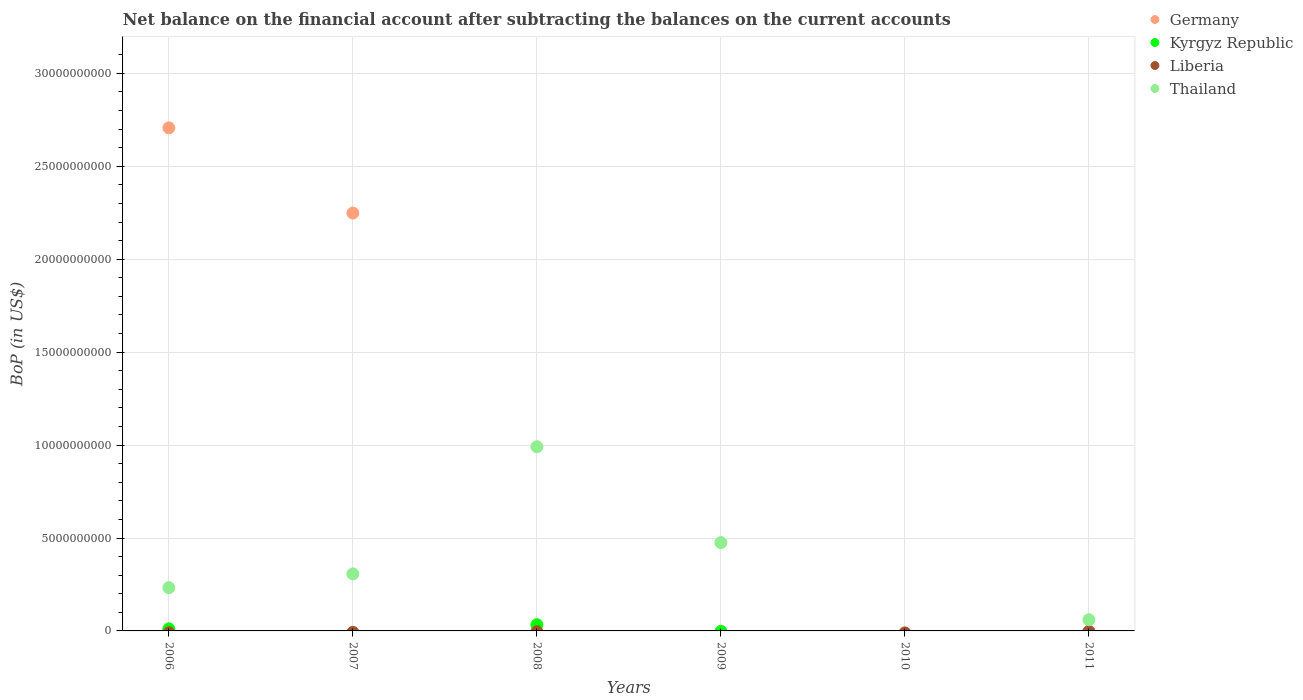Is the number of dotlines equal to the number of legend labels?
Your answer should be very brief. No. What is the Balance of Payments in Liberia in 2011?
Make the answer very short. 0. Across all years, what is the maximum Balance of Payments in Thailand?
Your response must be concise. 9.91e+09. What is the total Balance of Payments in Kyrgyz Republic in the graph?
Make the answer very short. 4.45e+08. What is the difference between the Balance of Payments in Germany in 2006 and that in 2007?
Your response must be concise. 4.58e+09. What is the difference between the Balance of Payments in Liberia in 2011 and the Balance of Payments in Thailand in 2009?
Give a very brief answer. -4.75e+09. What is the average Balance of Payments in Germany per year?
Your response must be concise. 8.26e+09. In the year 2007, what is the difference between the Balance of Payments in Thailand and Balance of Payments in Germany?
Offer a very short reply. -1.94e+1. What is the ratio of the Balance of Payments in Germany in 2006 to that in 2007?
Your answer should be very brief. 1.2. What is the difference between the highest and the lowest Balance of Payments in Thailand?
Ensure brevity in your answer.  9.91e+09. Is it the case that in every year, the sum of the Balance of Payments in Thailand and Balance of Payments in Liberia  is greater than the sum of Balance of Payments in Kyrgyz Republic and Balance of Payments in Germany?
Your response must be concise. No. Is the Balance of Payments in Thailand strictly less than the Balance of Payments in Germany over the years?
Your response must be concise. No. How many dotlines are there?
Your answer should be very brief. 3. Are the values on the major ticks of Y-axis written in scientific E-notation?
Provide a short and direct response. No. Does the graph contain grids?
Provide a short and direct response. Yes. What is the title of the graph?
Your answer should be very brief. Net balance on the financial account after subtracting the balances on the current accounts. Does "Saudi Arabia" appear as one of the legend labels in the graph?
Your answer should be very brief. No. What is the label or title of the X-axis?
Provide a succinct answer. Years. What is the label or title of the Y-axis?
Your response must be concise. BoP (in US$). What is the BoP (in US$) in Germany in 2006?
Keep it short and to the point. 2.71e+1. What is the BoP (in US$) of Kyrgyz Republic in 2006?
Keep it short and to the point. 1.10e+08. What is the BoP (in US$) of Thailand in 2006?
Provide a succinct answer. 2.33e+09. What is the BoP (in US$) in Germany in 2007?
Make the answer very short. 2.25e+1. What is the BoP (in US$) of Kyrgyz Republic in 2007?
Your response must be concise. 0. What is the BoP (in US$) of Liberia in 2007?
Make the answer very short. 0. What is the BoP (in US$) of Thailand in 2007?
Keep it short and to the point. 3.07e+09. What is the BoP (in US$) of Germany in 2008?
Give a very brief answer. 0. What is the BoP (in US$) of Kyrgyz Republic in 2008?
Your response must be concise. 3.34e+08. What is the BoP (in US$) in Thailand in 2008?
Provide a succinct answer. 9.91e+09. What is the BoP (in US$) in Germany in 2009?
Your response must be concise. 0. What is the BoP (in US$) of Thailand in 2009?
Give a very brief answer. 4.75e+09. What is the BoP (in US$) in Germany in 2011?
Ensure brevity in your answer.  0. What is the BoP (in US$) in Kyrgyz Republic in 2011?
Give a very brief answer. 0. What is the BoP (in US$) of Thailand in 2011?
Your answer should be compact. 6.01e+08. Across all years, what is the maximum BoP (in US$) of Germany?
Offer a very short reply. 2.71e+1. Across all years, what is the maximum BoP (in US$) of Kyrgyz Republic?
Keep it short and to the point. 3.34e+08. Across all years, what is the maximum BoP (in US$) of Thailand?
Provide a succinct answer. 9.91e+09. Across all years, what is the minimum BoP (in US$) of Germany?
Your response must be concise. 0. Across all years, what is the minimum BoP (in US$) in Thailand?
Ensure brevity in your answer.  0. What is the total BoP (in US$) of Germany in the graph?
Provide a short and direct response. 4.96e+1. What is the total BoP (in US$) in Kyrgyz Republic in the graph?
Provide a succinct answer. 4.45e+08. What is the total BoP (in US$) in Liberia in the graph?
Your response must be concise. 0. What is the total BoP (in US$) of Thailand in the graph?
Make the answer very short. 2.07e+1. What is the difference between the BoP (in US$) of Germany in 2006 and that in 2007?
Give a very brief answer. 4.58e+09. What is the difference between the BoP (in US$) of Thailand in 2006 and that in 2007?
Ensure brevity in your answer.  -7.42e+08. What is the difference between the BoP (in US$) in Kyrgyz Republic in 2006 and that in 2008?
Your answer should be very brief. -2.24e+08. What is the difference between the BoP (in US$) in Thailand in 2006 and that in 2008?
Offer a terse response. -7.58e+09. What is the difference between the BoP (in US$) of Thailand in 2006 and that in 2009?
Offer a very short reply. -2.42e+09. What is the difference between the BoP (in US$) in Thailand in 2006 and that in 2011?
Your answer should be very brief. 1.73e+09. What is the difference between the BoP (in US$) of Thailand in 2007 and that in 2008?
Your response must be concise. -6.84e+09. What is the difference between the BoP (in US$) in Thailand in 2007 and that in 2009?
Ensure brevity in your answer.  -1.68e+09. What is the difference between the BoP (in US$) in Thailand in 2007 and that in 2011?
Provide a succinct answer. 2.47e+09. What is the difference between the BoP (in US$) of Thailand in 2008 and that in 2009?
Provide a short and direct response. 5.16e+09. What is the difference between the BoP (in US$) of Thailand in 2008 and that in 2011?
Give a very brief answer. 9.31e+09. What is the difference between the BoP (in US$) in Thailand in 2009 and that in 2011?
Give a very brief answer. 4.15e+09. What is the difference between the BoP (in US$) in Germany in 2006 and the BoP (in US$) in Thailand in 2007?
Your response must be concise. 2.40e+1. What is the difference between the BoP (in US$) of Kyrgyz Republic in 2006 and the BoP (in US$) of Thailand in 2007?
Your answer should be compact. -2.96e+09. What is the difference between the BoP (in US$) in Germany in 2006 and the BoP (in US$) in Kyrgyz Republic in 2008?
Make the answer very short. 2.67e+1. What is the difference between the BoP (in US$) of Germany in 2006 and the BoP (in US$) of Thailand in 2008?
Ensure brevity in your answer.  1.72e+1. What is the difference between the BoP (in US$) in Kyrgyz Republic in 2006 and the BoP (in US$) in Thailand in 2008?
Your answer should be very brief. -9.80e+09. What is the difference between the BoP (in US$) of Germany in 2006 and the BoP (in US$) of Thailand in 2009?
Keep it short and to the point. 2.23e+1. What is the difference between the BoP (in US$) of Kyrgyz Republic in 2006 and the BoP (in US$) of Thailand in 2009?
Provide a succinct answer. -4.64e+09. What is the difference between the BoP (in US$) in Germany in 2006 and the BoP (in US$) in Thailand in 2011?
Make the answer very short. 2.65e+1. What is the difference between the BoP (in US$) in Kyrgyz Republic in 2006 and the BoP (in US$) in Thailand in 2011?
Give a very brief answer. -4.90e+08. What is the difference between the BoP (in US$) of Germany in 2007 and the BoP (in US$) of Kyrgyz Republic in 2008?
Keep it short and to the point. 2.22e+1. What is the difference between the BoP (in US$) in Germany in 2007 and the BoP (in US$) in Thailand in 2008?
Make the answer very short. 1.26e+1. What is the difference between the BoP (in US$) of Germany in 2007 and the BoP (in US$) of Thailand in 2009?
Make the answer very short. 1.77e+1. What is the difference between the BoP (in US$) of Germany in 2007 and the BoP (in US$) of Thailand in 2011?
Provide a succinct answer. 2.19e+1. What is the difference between the BoP (in US$) of Kyrgyz Republic in 2008 and the BoP (in US$) of Thailand in 2009?
Your response must be concise. -4.42e+09. What is the difference between the BoP (in US$) of Kyrgyz Republic in 2008 and the BoP (in US$) of Thailand in 2011?
Keep it short and to the point. -2.66e+08. What is the average BoP (in US$) of Germany per year?
Your answer should be compact. 8.26e+09. What is the average BoP (in US$) of Kyrgyz Republic per year?
Keep it short and to the point. 7.41e+07. What is the average BoP (in US$) of Liberia per year?
Provide a succinct answer. 0. What is the average BoP (in US$) of Thailand per year?
Offer a terse response. 3.44e+09. In the year 2006, what is the difference between the BoP (in US$) of Germany and BoP (in US$) of Kyrgyz Republic?
Provide a short and direct response. 2.70e+1. In the year 2006, what is the difference between the BoP (in US$) of Germany and BoP (in US$) of Thailand?
Provide a succinct answer. 2.47e+1. In the year 2006, what is the difference between the BoP (in US$) of Kyrgyz Republic and BoP (in US$) of Thailand?
Make the answer very short. -2.22e+09. In the year 2007, what is the difference between the BoP (in US$) in Germany and BoP (in US$) in Thailand?
Give a very brief answer. 1.94e+1. In the year 2008, what is the difference between the BoP (in US$) of Kyrgyz Republic and BoP (in US$) of Thailand?
Make the answer very short. -9.57e+09. What is the ratio of the BoP (in US$) of Germany in 2006 to that in 2007?
Provide a short and direct response. 1.2. What is the ratio of the BoP (in US$) of Thailand in 2006 to that in 2007?
Ensure brevity in your answer.  0.76. What is the ratio of the BoP (in US$) of Kyrgyz Republic in 2006 to that in 2008?
Give a very brief answer. 0.33. What is the ratio of the BoP (in US$) in Thailand in 2006 to that in 2008?
Make the answer very short. 0.23. What is the ratio of the BoP (in US$) of Thailand in 2006 to that in 2009?
Ensure brevity in your answer.  0.49. What is the ratio of the BoP (in US$) of Thailand in 2006 to that in 2011?
Ensure brevity in your answer.  3.87. What is the ratio of the BoP (in US$) of Thailand in 2007 to that in 2008?
Offer a very short reply. 0.31. What is the ratio of the BoP (in US$) of Thailand in 2007 to that in 2009?
Make the answer very short. 0.65. What is the ratio of the BoP (in US$) of Thailand in 2007 to that in 2011?
Provide a succinct answer. 5.11. What is the ratio of the BoP (in US$) in Thailand in 2008 to that in 2009?
Ensure brevity in your answer.  2.09. What is the ratio of the BoP (in US$) in Thailand in 2008 to that in 2011?
Offer a terse response. 16.5. What is the ratio of the BoP (in US$) of Thailand in 2009 to that in 2011?
Offer a terse response. 7.91. What is the difference between the highest and the second highest BoP (in US$) in Thailand?
Your answer should be compact. 5.16e+09. What is the difference between the highest and the lowest BoP (in US$) of Germany?
Give a very brief answer. 2.71e+1. What is the difference between the highest and the lowest BoP (in US$) of Kyrgyz Republic?
Make the answer very short. 3.34e+08. What is the difference between the highest and the lowest BoP (in US$) of Thailand?
Make the answer very short. 9.91e+09. 